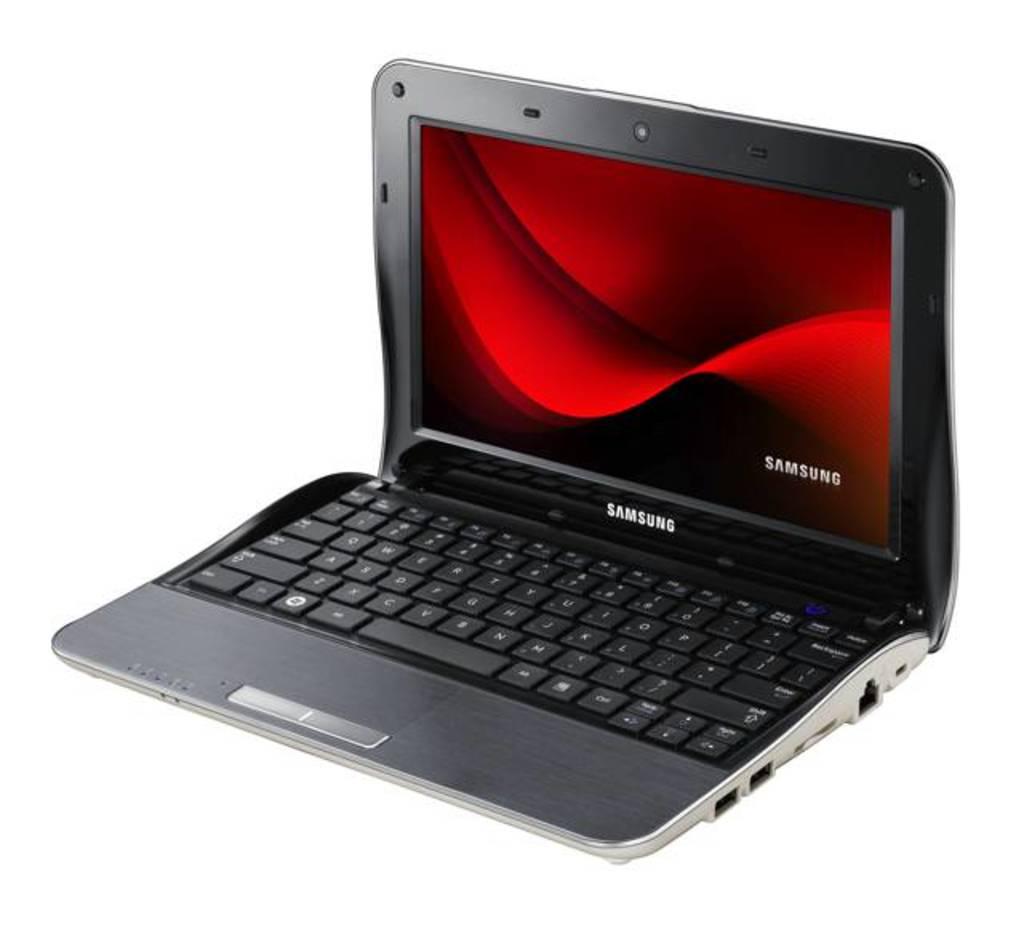What brand of laptop is this?
Keep it short and to the point. Samsung. 